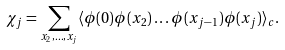<formula> <loc_0><loc_0><loc_500><loc_500>\chi _ { j } = \sum _ { x _ { 2 } , \dots , x _ { j } } \langle \phi ( 0 ) \phi ( x _ { 2 } ) \dots \phi ( x _ { j - 1 } ) \phi ( x _ { j } ) \rangle _ { c } .</formula> 